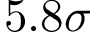<formula> <loc_0><loc_0><loc_500><loc_500>5 . 8 \sigma</formula> 